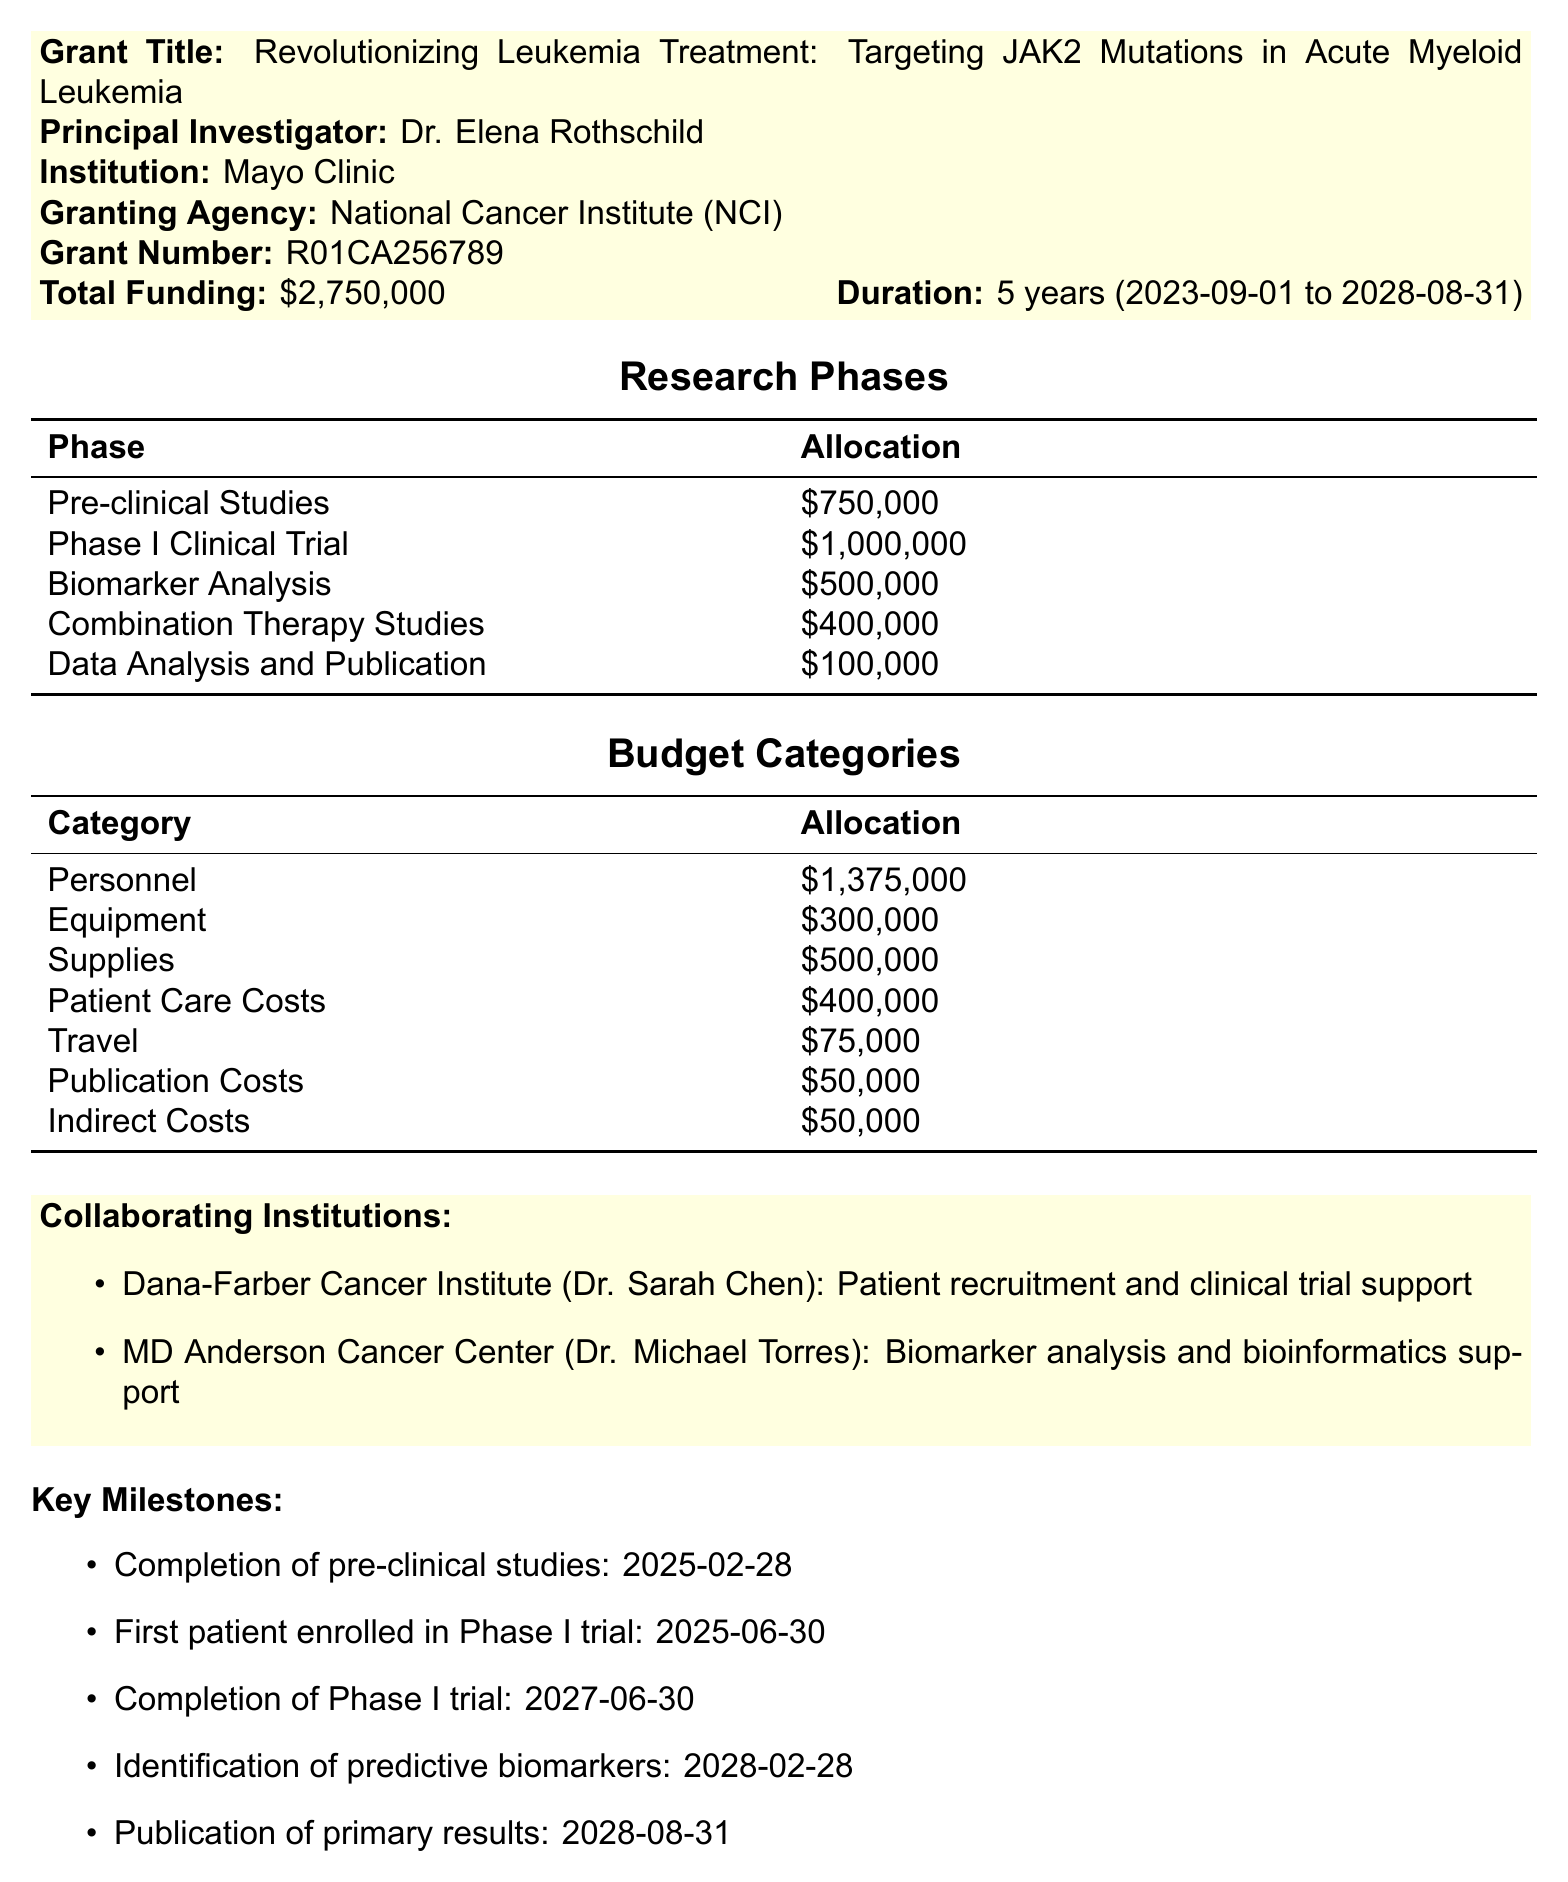What is the grant title? The grant title is explicitly mentioned in the document as the main subject of the study.
Answer: Revolutionizing Leukemia Treatment: Targeting JAK2 Mutations in Acute Myeloid Leukemia Who is the principal investigator? The document specifies the principal investigator responsible for the study.
Answer: Dr. Elena Rothschild What is the total funding amount? The total funding amount is clearly stated in the financial summary section of the document.
Answer: $2,750,000 How long is the project duration? The project duration outlines the start and end dates, indicating the overall timeframe for the study.
Answer: 5 years What is the allocation for the Phase I Clinical Trial? The allocation for each research phase is summarized, highlighting specific funding for the Phase I trial.
Answer: $1,000,000 In which month is the first patient enrolled in the Phase I trial scheduled? The document lists key milestones, including the expected date for enrollment in the clinical trial.
Answer: June Which institution collaborates for patient recruitment? The collaborating institutions are mentioned along with their roles in the study.
Answer: Dana-Farber Cancer Institute What is the total allocation for personnel? The budget categories detail the financial allocations for various expenses, including personnel.
Answer: $1,375,000 What is the expected date for the completion of pre-clinical studies? The document specifies key milestones along with their expected dates, including the pre-clinical studies.
Answer: 2025-02-28 